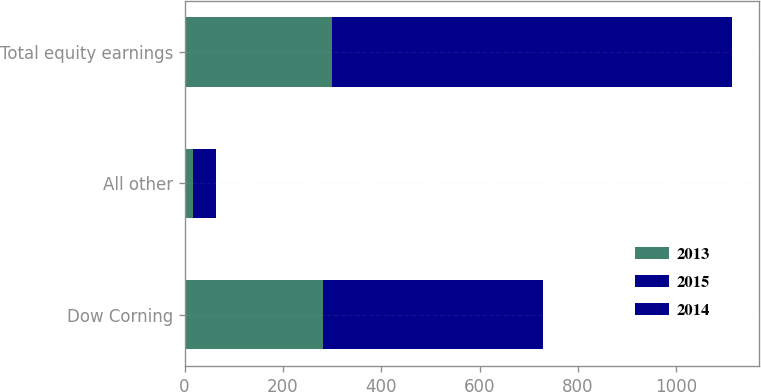<chart> <loc_0><loc_0><loc_500><loc_500><stacked_bar_chart><ecel><fcel>Dow Corning<fcel>All other<fcel>Total equity earnings<nl><fcel>2013<fcel>281<fcel>18<fcel>299<nl><fcel>2015<fcel>252<fcel>14<fcel>266<nl><fcel>2014<fcel>196<fcel>31<fcel>547<nl></chart> 